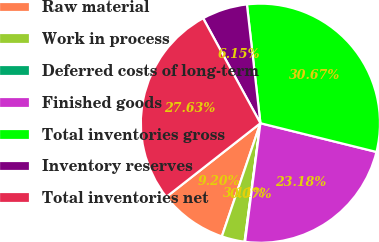Convert chart to OTSL. <chart><loc_0><loc_0><loc_500><loc_500><pie_chart><fcel>Raw material<fcel>Work in process<fcel>Deferred costs of long-term<fcel>Finished goods<fcel>Total inventories gross<fcel>Inventory reserves<fcel>Total inventories net<nl><fcel>9.2%<fcel>3.11%<fcel>0.07%<fcel>23.18%<fcel>30.67%<fcel>6.15%<fcel>27.63%<nl></chart> 